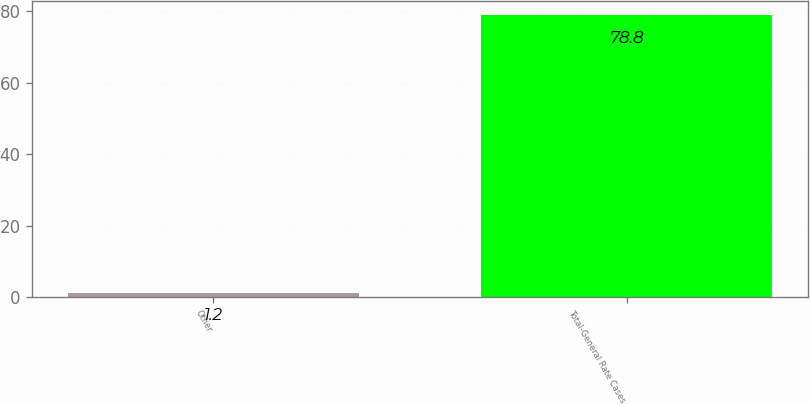Convert chart. <chart><loc_0><loc_0><loc_500><loc_500><bar_chart><fcel>Other<fcel>Total-General Rate Cases<nl><fcel>1.2<fcel>78.8<nl></chart> 